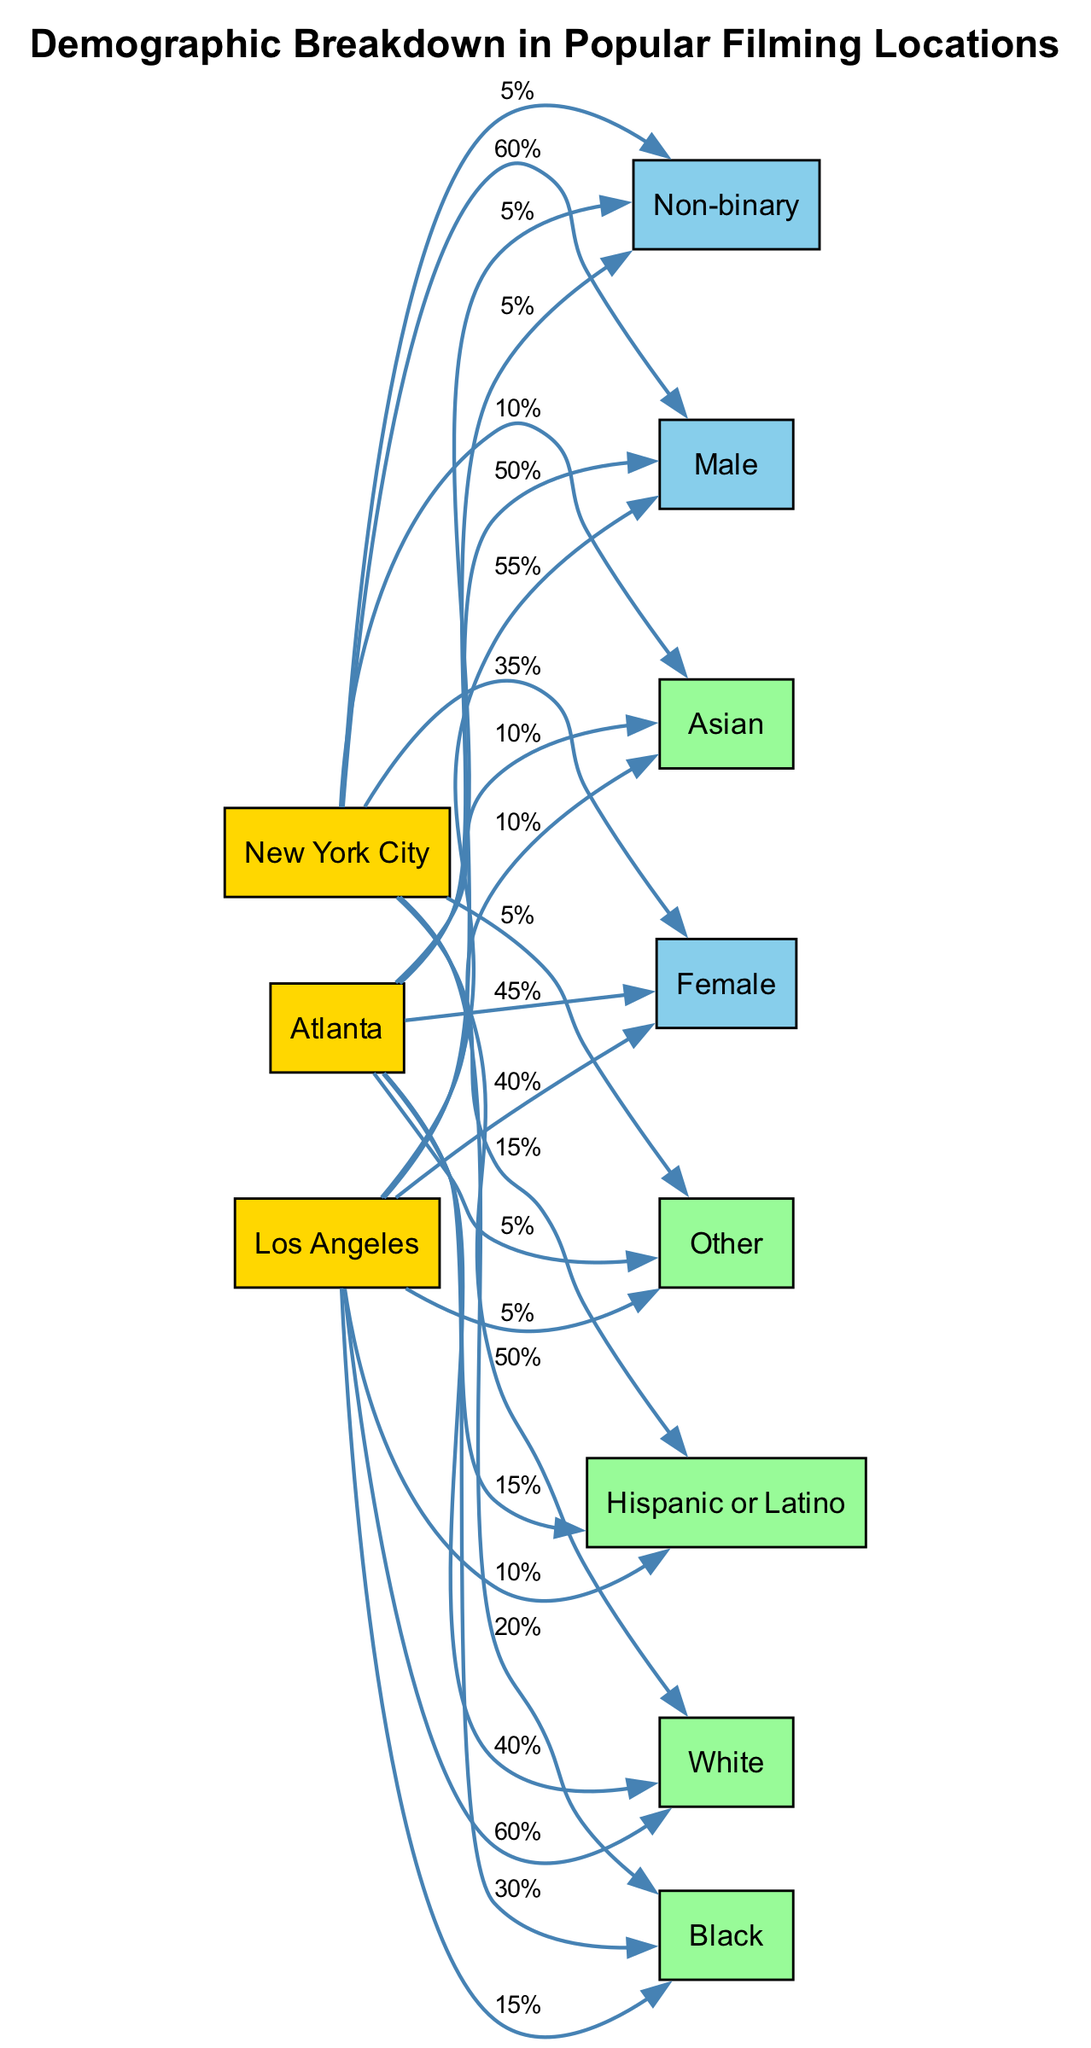What percentage of female crew members are in Los Angeles? The edge connecting "Los Angeles" and "Female" shows a label of "40%", indicating that the percentage of female crew members is 40%.
Answer: 40% How many nodes represent different demographics in this diagram? There are 8 nodes representing different demographics (Female, Male, Non-binary, White, Black, Hispanic or Latino, Asian, Other), identified among the total nodes in the diagram.
Answer: 8 What is the percentage of male crew members in New York City? The connection from "New York City" to "Male" indicates a label of "60%", which means that the percentage of male crew members is 60% in that location.
Answer: 60% Which filming location has the highest percentage of Black crew members? By comparing the percentages of Black crew members for each location, Atlanta is connected to Black with a label of "30%", which is the highest compared to 20% for New York City and 15% for Los Angeles.
Answer: Atlanta Are there any non-binary crew members in these locations? Each location has edges leading to the Non-binary node with a consistent label of "5%", indicating that there are non-binary crew members present in all three locations, although the percentage is the same across the board.
Answer: Yes What is the percentage of Hispanic or Latino crew members in Atlanta? The connection from "Atlanta" to "Hispanic or Latino" shows a label of "15%", confirming that the percentage of Hispanic or Latino crew members in Atlanta is 15%.
Answer: 15% Which demographic has the lowest representation in New York City? By examining the edges from New York City, "Non-binary" is represented with a label of "5%", indicating it has the lowest representation in that location.
Answer: Non-binary What percentage of male crew members is in Atlanta compared to Los Angeles? Atlanta has a "50%" connection to Male, while Los Angeles has "55%". This means Los Angeles has a slightly higher percentage of male crew members compared to Atlanta.
Answer: Los Angeles (55%) What demographic represents the highest percentage in Los Angeles? The connection to "Male" from Los Angeles shows a label of "55%", which is the highest percentage demographic represented in that location.
Answer: Male 